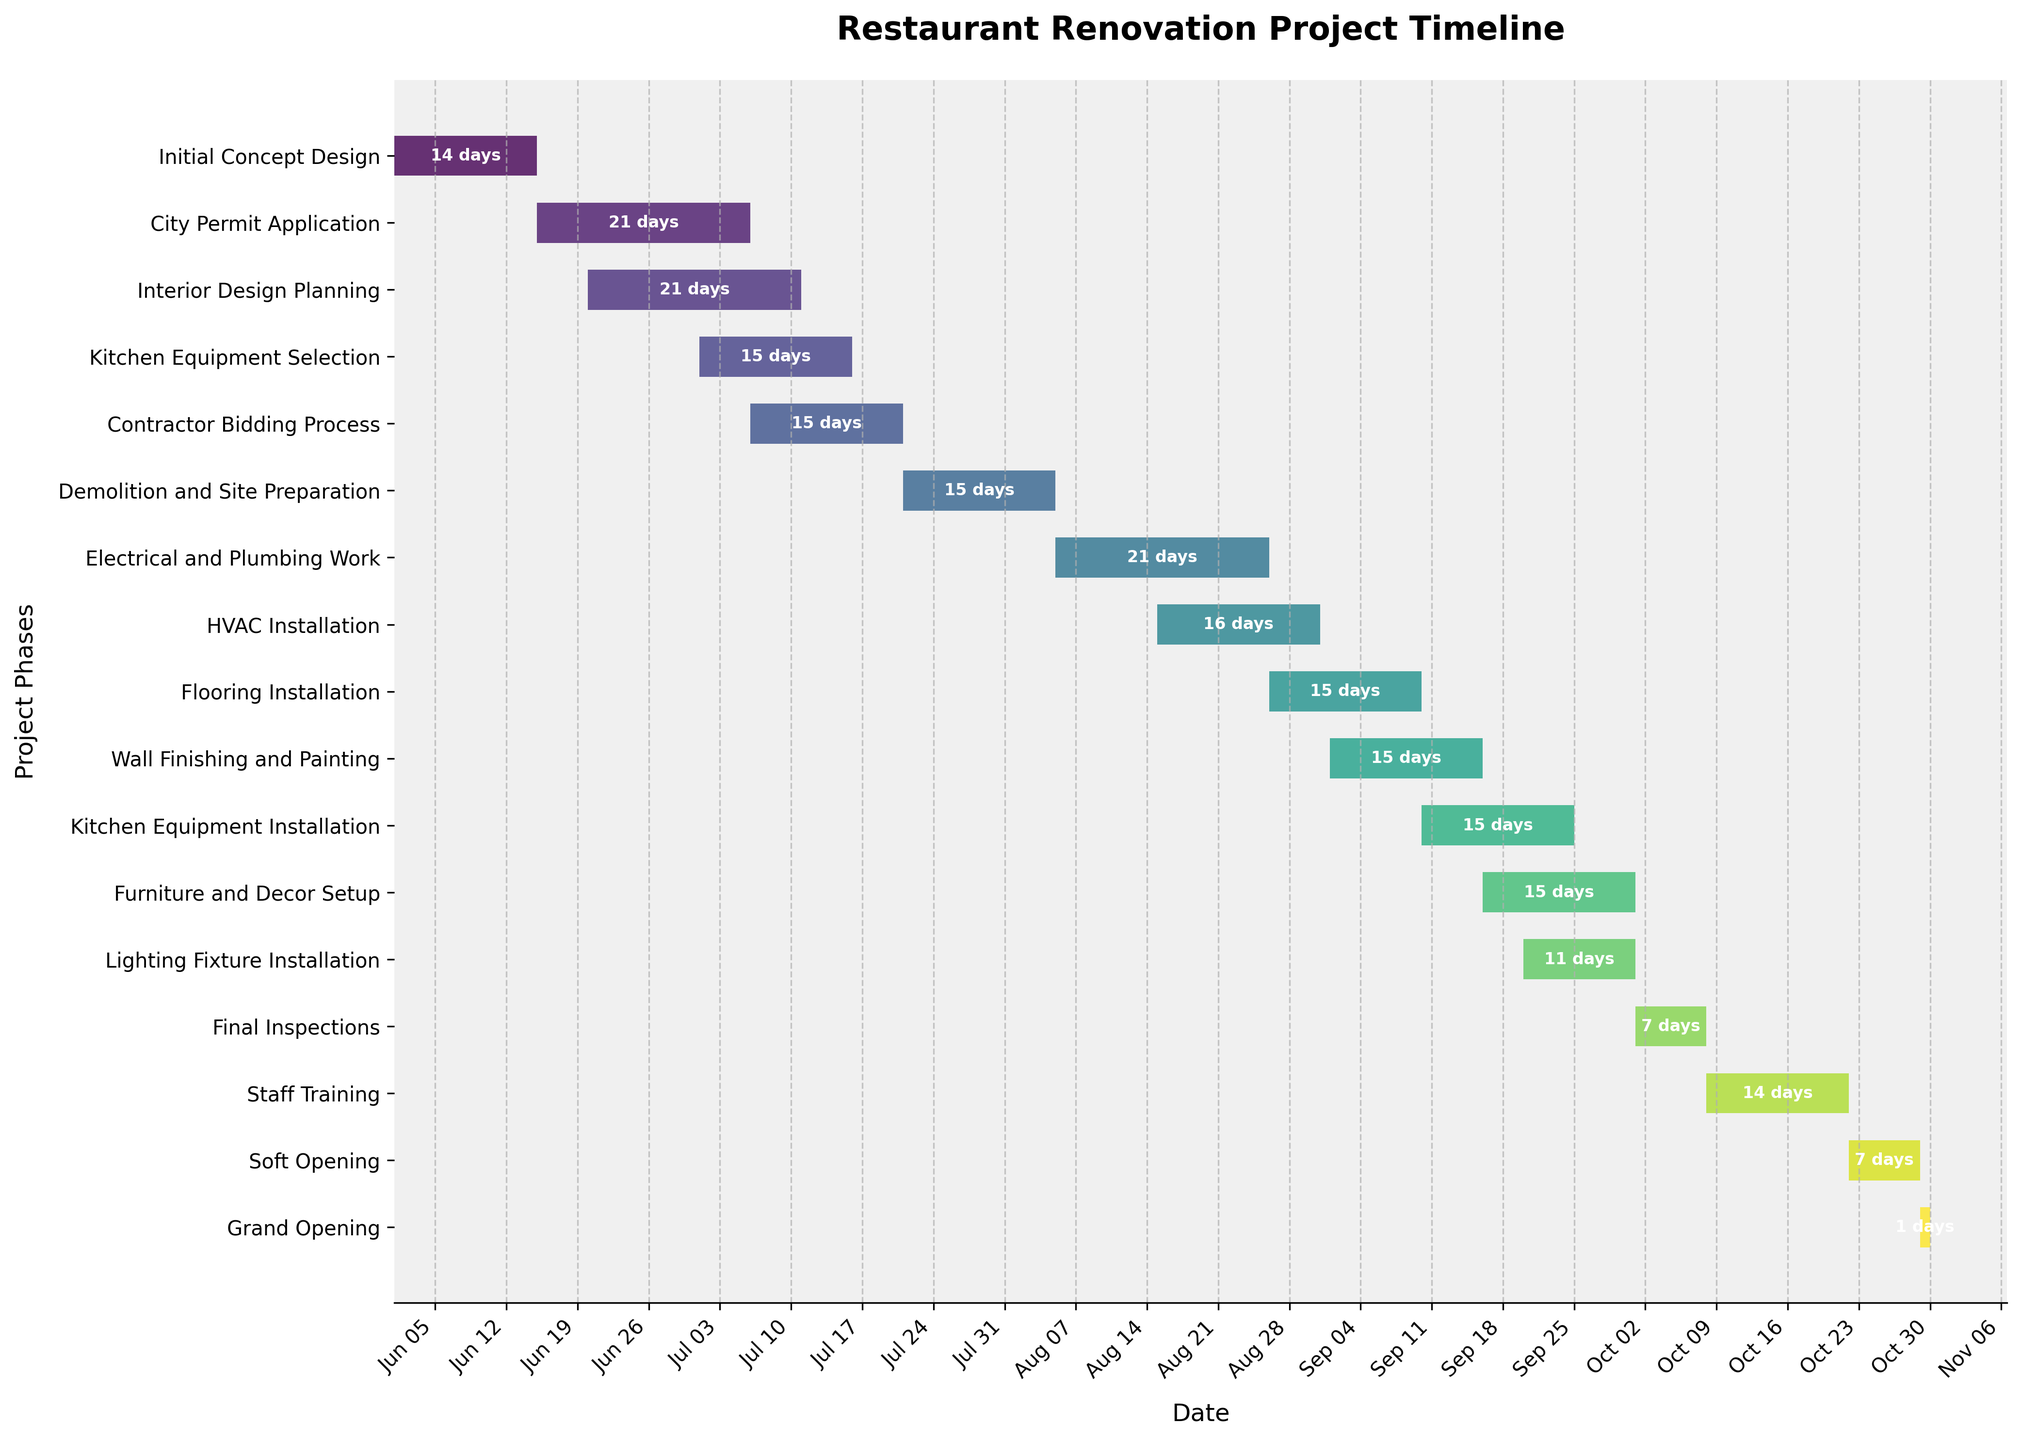What is the title of the Gantt Chart? The title is usually found at the top of the chart. In this case, it is indicated in the code as "Restaurant Renovation Project Timeline".
Answer: Restaurant Renovation Project Timeline How long is the "Initial Concept Design" phase? Find "Initial Concept Design" on the y-axis and look at the bar's length. The duration is labeled directly on the bar.
Answer: 14 days Which phase has the shortest duration, and what is it? The phase with the shortest bar on the Gantt chart represents the shortest duration. "Grand Opening" bar is the shortest.
Answer: Grand Opening, 1 day Which tasks overlap with "Interior Design Planning"? Check the bar for "Interior Design Planning" and find other bars starting or ending within its time frame. "City Permit Application" and "Kitchen Equipment Selection" overlap with it.
Answer: City Permit Application, Kitchen Equipment Selection What is the duration between the start of "City Permit Application" and the start of "HVAC Installation"? Find the start dates of both tasks and calculate the days in between. "City Permit Application" starts on 2023-06-15, and "HVAC Installation" starts on 2023-08-15.
Answer: 61 days Which phase immediately follows "Electrical and Plumbing Work"? Find "Electrical and Plumbing Work" and check which bar starts right after its end date. "HVAC Installation" is the next phase.
Answer: HVAC Installation During which phase does "Final Inspections" occur? Look at the start and end date of "Final Inspections" and see if other bars overlap with these dates. It overlaps with "Staff Training".
Answer: Staff Training How many phases are planned between "Demolition and Site Preparation" and "Furniture and Decor Setup"? Count the number of bars between these two tasks.
Answer: Six What is the total duration from the start of "Demolition and Site Preparation" to the end of "Grand Opening"? Find the start date of "Demolition and Site Preparation", which is 2023-07-21, and the end date of "Grand Opening", which is 2023-10-29, then calculate the difference in days.
Answer: 101 days What is the average duration of all tasks? Sum the durations of all tasks and divide by the total number of tasks. Here, the sum of durations is 228 days, and there are 17 tasks. So, the average is 228/17.
Answer: 13.41 days 